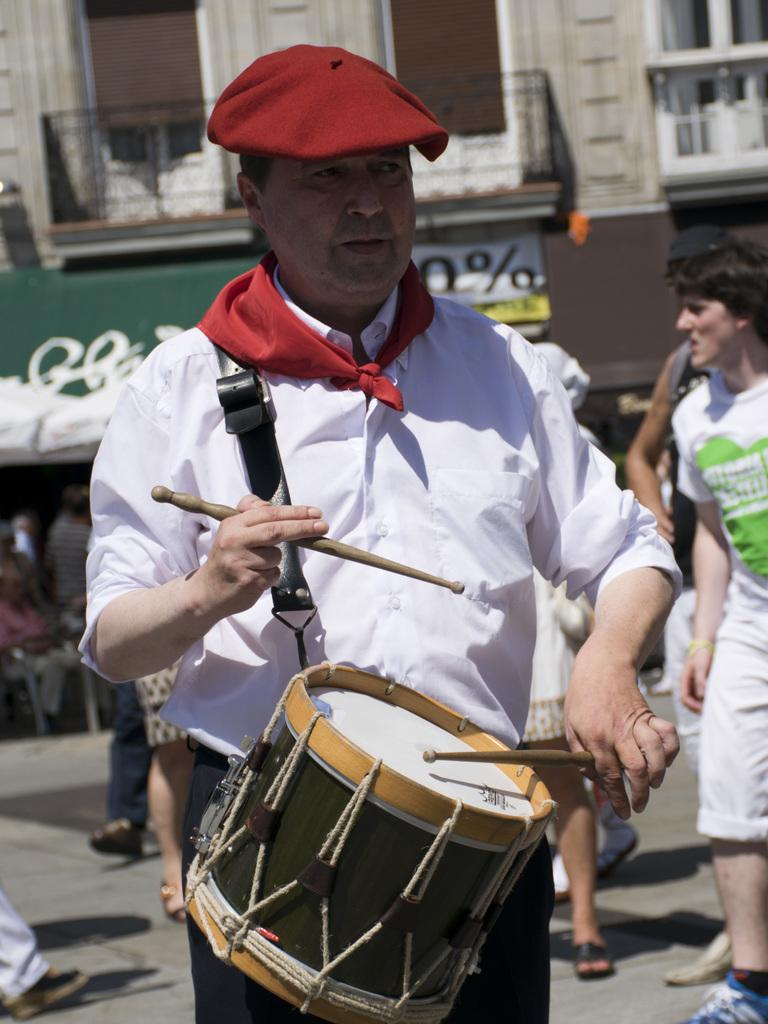What is the man in the image wearing on his head? The man is wearing a red cap. What is the man wearing around his neck? The man is wearing a scarf around his neck. What is the man doing in the image? The man is playing drums. What can be seen in the background of the image? There is a building with windows and a balcony in the background, and there are people walking. What type of work does the fireman do in the image? There is no fireman present in the image, so it is not possible to answer that question. 